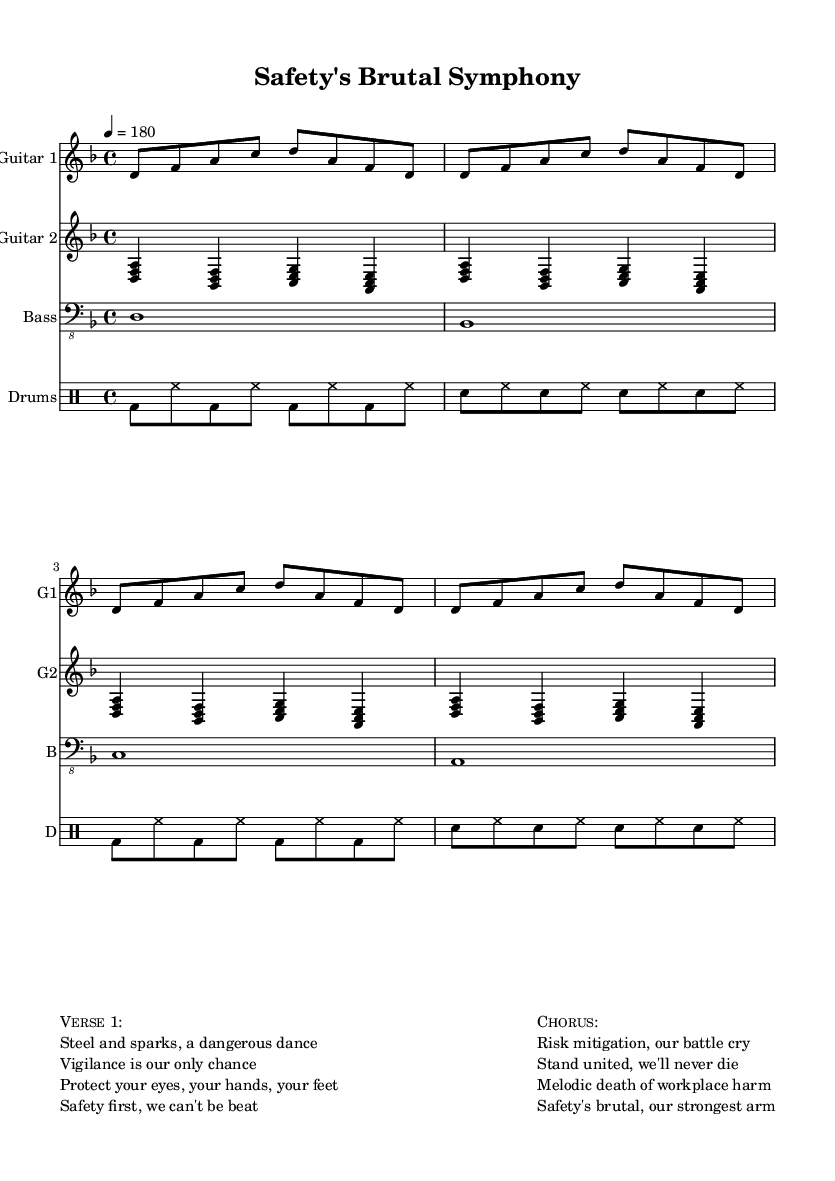What is the time signature of this piece? The time signature is indicated next to the clef and is shown as 4/4 in the sheet music. This means there are four beats per measure, and the quarter note receives one beat.
Answer: 4/4 What is the key signature of this song? The key signature is D minor, as indicated at the beginning of the music sheet with one flat (B♭) noted in the key context.
Answer: D minor What is the tempo marking for this song? The tempo marking at the beginning states 4 = 180, which indicates the number of beats per minute (BPM) in the piece. This means that the quarter note should be played at a rapid speed of 180 BPM.
Answer: 180 How many measures are there in the main guitar part? Each guitar part consists of 4 measures, and since there are two guitar parts and we see them repeated, we multiply the 4 measures by the number of repetitions. Thus, the main repeated section is 4 measures long.
Answer: 4 What is the central theme of the chorus? The chorus emphasizes risk mitigation and unity in the face of workplace dangers, aligning with the overall theme of workplace safety as depicted in the lyrics.
Answer: Risk mitigation What instruments are featured in this composition? The composition includes guitars, a bass, and drums, which are all explicitly notated in the score. Each instrument has its designated staff that indicates the specific parts being played.
Answer: Guitars, bass, drums What lyrical message does the first verse convey? The first verse focuses on the importance of vigilance and safety in a potentially dangerous environment, urging to protect oneself while working, which is also reiterated in the following chorus.
Answer: Vigilance and safety 